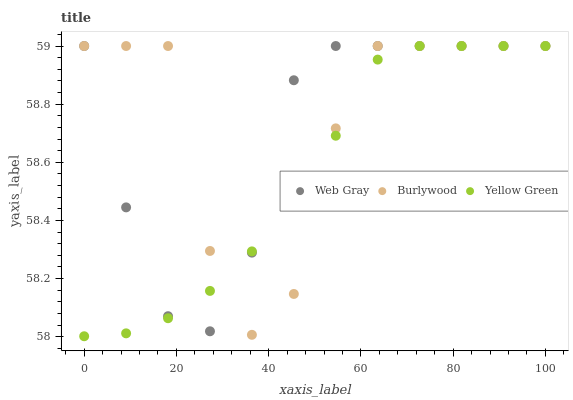Does Yellow Green have the minimum area under the curve?
Answer yes or no. Yes. Does Burlywood have the maximum area under the curve?
Answer yes or no. Yes. Does Web Gray have the minimum area under the curve?
Answer yes or no. No. Does Web Gray have the maximum area under the curve?
Answer yes or no. No. Is Yellow Green the smoothest?
Answer yes or no. Yes. Is Burlywood the roughest?
Answer yes or no. Yes. Is Web Gray the smoothest?
Answer yes or no. No. Is Web Gray the roughest?
Answer yes or no. No. Does Yellow Green have the lowest value?
Answer yes or no. Yes. Does Web Gray have the lowest value?
Answer yes or no. No. Does Yellow Green have the highest value?
Answer yes or no. Yes. Does Web Gray intersect Burlywood?
Answer yes or no. Yes. Is Web Gray less than Burlywood?
Answer yes or no. No. Is Web Gray greater than Burlywood?
Answer yes or no. No. 